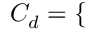Convert formula to latex. <formula><loc_0><loc_0><loc_500><loc_500>C _ { d } = \left \{ \begin{array} { r l r l } \end{array}</formula> 